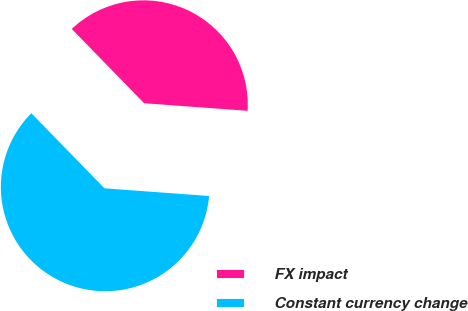<chart> <loc_0><loc_0><loc_500><loc_500><pie_chart><fcel>FX impact<fcel>Constant currency change<nl><fcel>38.46%<fcel>61.54%<nl></chart> 